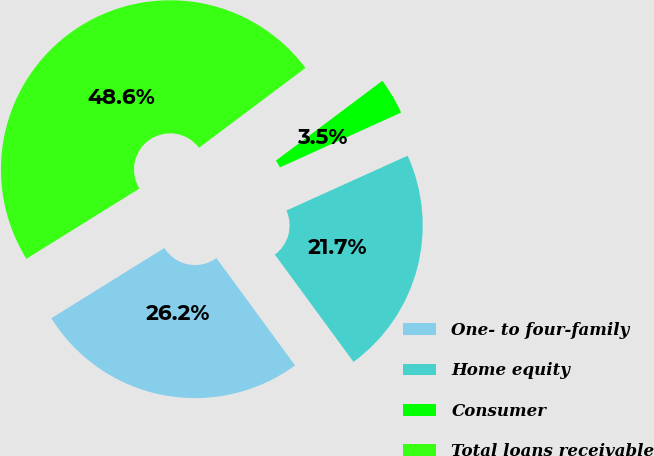<chart> <loc_0><loc_0><loc_500><loc_500><pie_chart><fcel>One- to four-family<fcel>Home equity<fcel>Consumer<fcel>Total loans receivable<nl><fcel>26.21%<fcel>21.7%<fcel>3.48%<fcel>48.61%<nl></chart> 